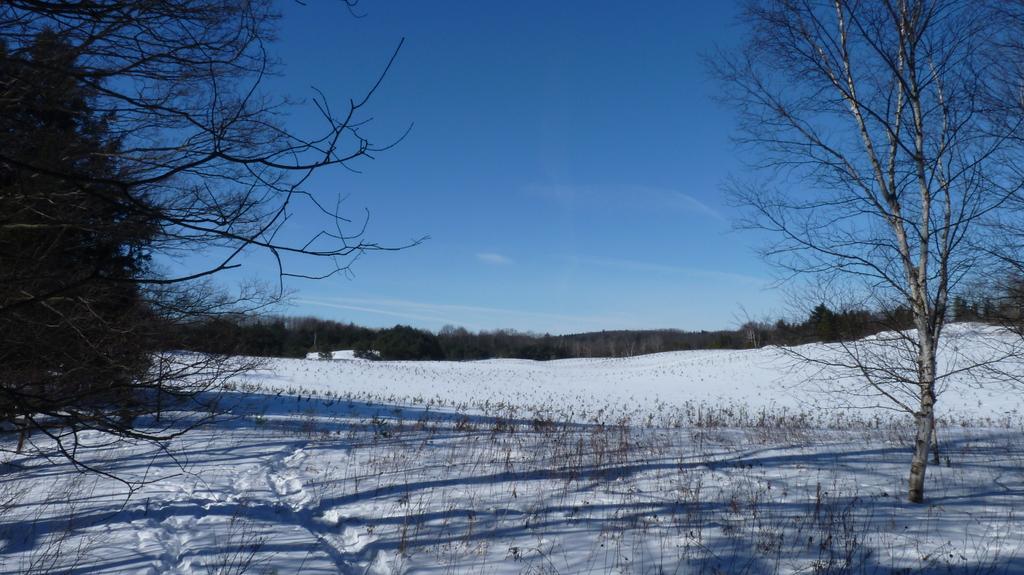How would you summarize this image in a sentence or two? In this image at the bottom we can see bare plants and trees on the snow. In the background there are trees and clouds in the sky. 